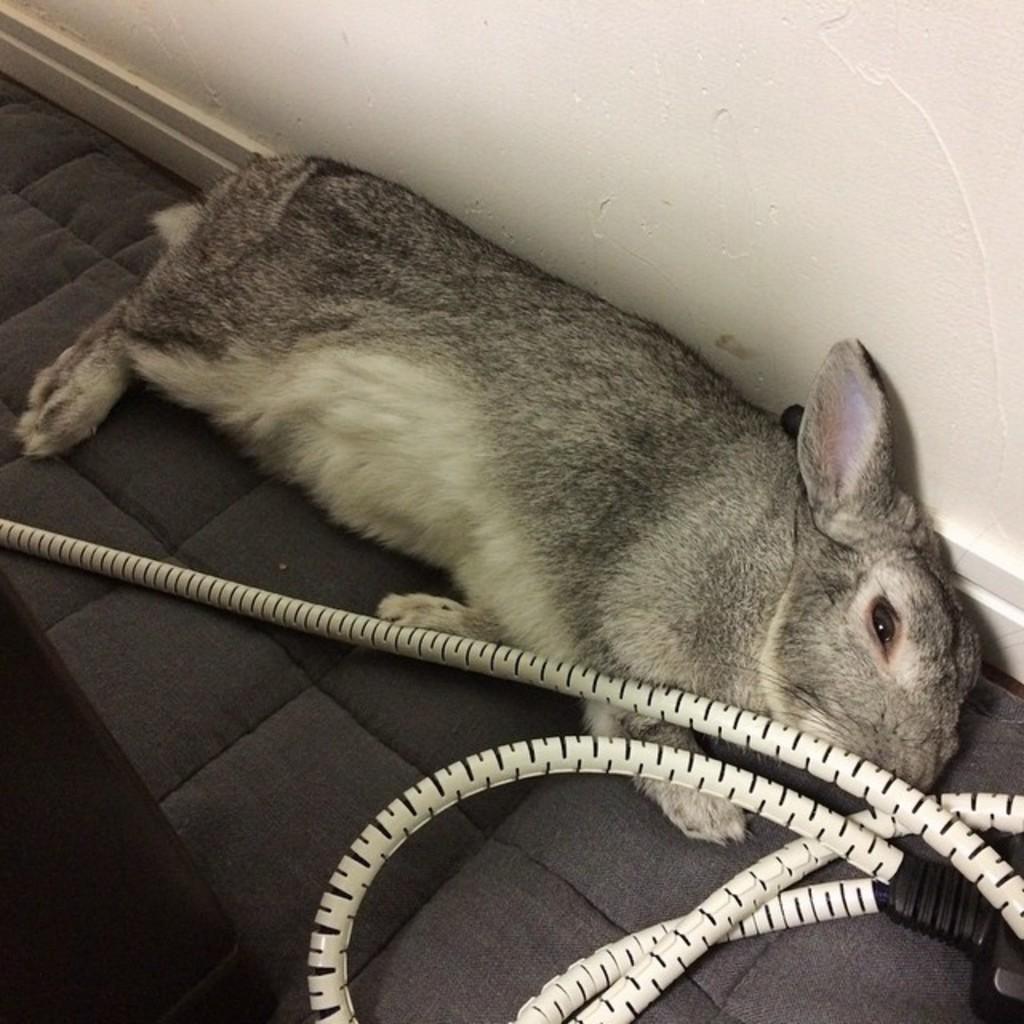How would you summarize this image in a sentence or two? In this picture I can see there is a rabbit lying on the floor and there is a cable, there is a white wall in the backdrop. 